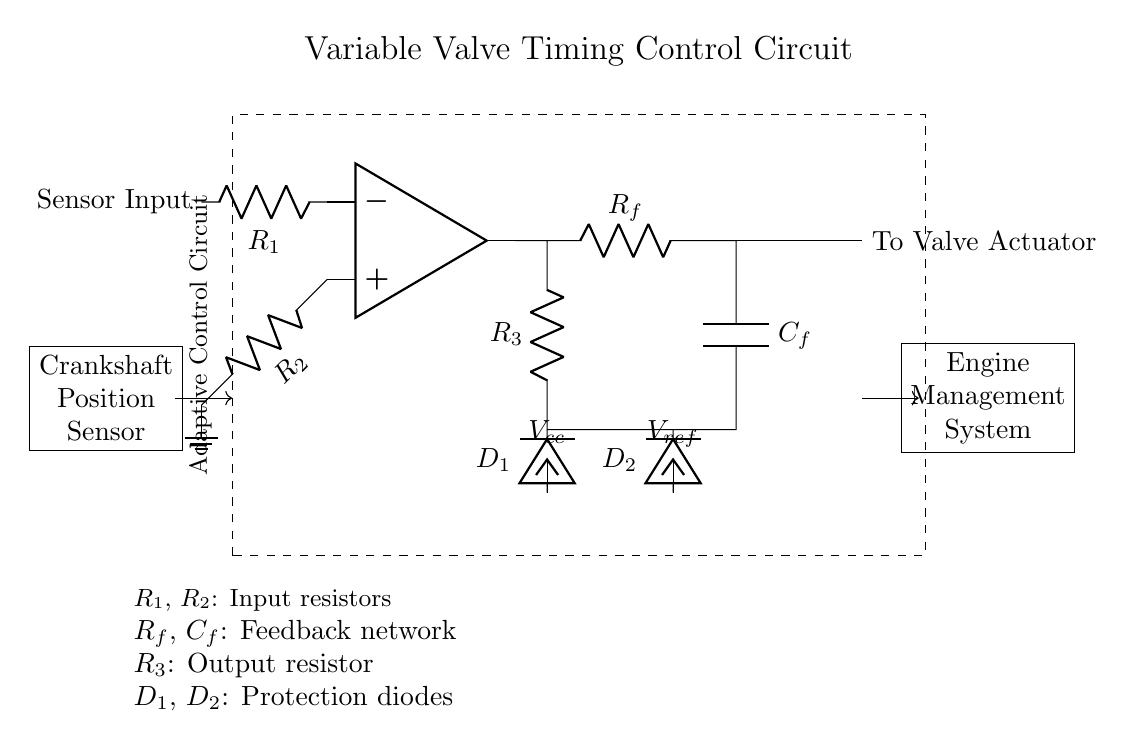What is the input to the op amp? The input to the op amp is connected to R1, which is labeled as the Sensor Input. This indicates it's getting a signal from a sensor related to the engine's performance.
Answer: Sensor Input What are the protection diodes labeled as? The protection diodes are labeled D1 and D2 in the circuit diagram. Each diode helps protect connected components from potential over-voltage conditions.
Answer: D1, D2 How many resistors are there in total in the circuit? There are four resistors present in the circuit: R1, R2, R3, and Rf. These resistors play different roles in establishing the feedback and controlling the op amp's function.
Answer: Four What does Vcc represent in the circuit? Vcc represents the supply voltage for the circuit. Specifically, it’s the voltage supplied to the components, playing a crucial role in their operation.
Answer: Supply voltage How does the output from the circuit reach the valve actuator? The output from the op amp routes directly to the valve actuator via a resistor labeled R3. This resistor typically controls the amount of current flowing to the actuator.
Answer: R3 What type of circuit is this? This is an adaptive control circuit, indicated by the label on the dashed rectangle surrounding the main components. The function of this circuit is to adaptively control variable valve timing.
Answer: Adaptive Control Circuit What role does the capacitor play in the feedback network? The capacitor, specified as C_f, works with the feedback resistor R_f to set the time constant of the circuit, impacting how quickly it reacts to changing inputs from the sensor.
Answer: Feedback timing 